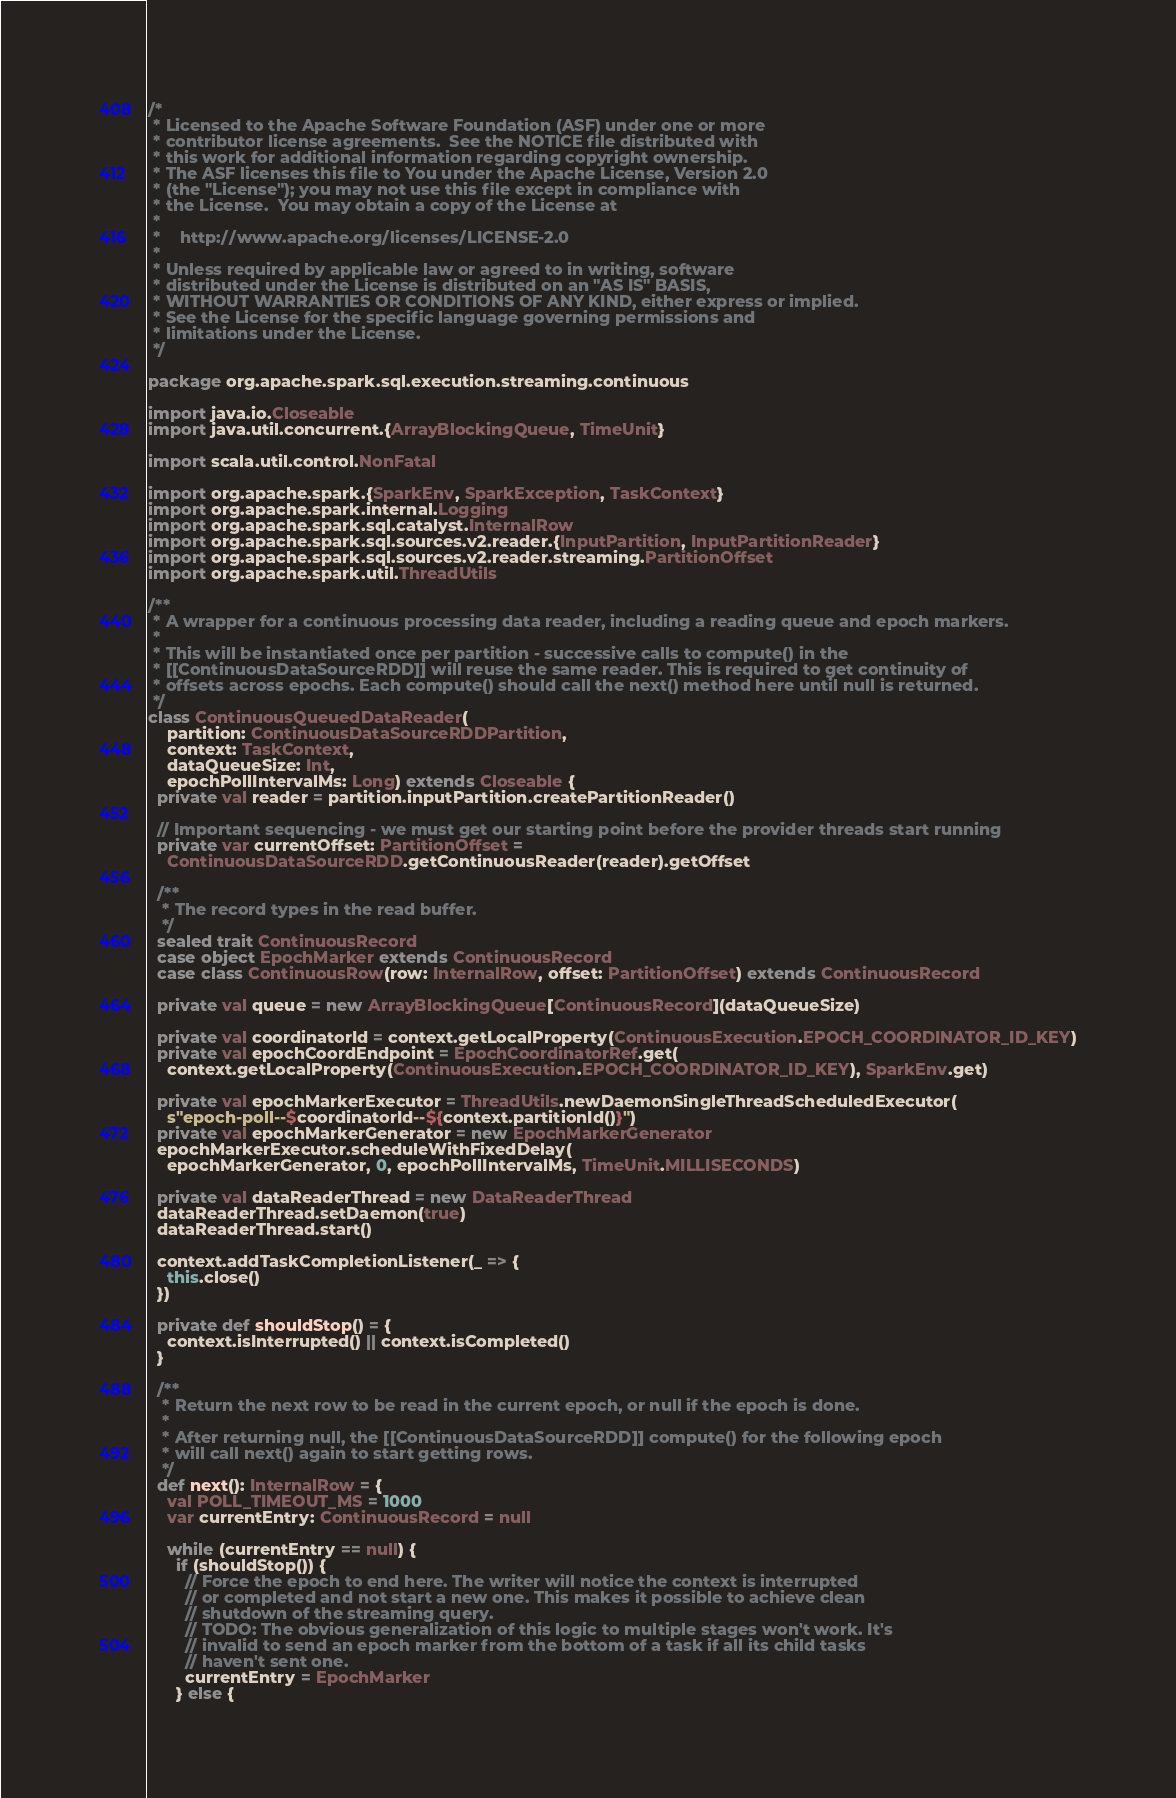<code> <loc_0><loc_0><loc_500><loc_500><_Scala_>/*
 * Licensed to the Apache Software Foundation (ASF) under one or more
 * contributor license agreements.  See the NOTICE file distributed with
 * this work for additional information regarding copyright ownership.
 * The ASF licenses this file to You under the Apache License, Version 2.0
 * (the "License"); you may not use this file except in compliance with
 * the License.  You may obtain a copy of the License at
 *
 *    http://www.apache.org/licenses/LICENSE-2.0
 *
 * Unless required by applicable law or agreed to in writing, software
 * distributed under the License is distributed on an "AS IS" BASIS,
 * WITHOUT WARRANTIES OR CONDITIONS OF ANY KIND, either express or implied.
 * See the License for the specific language governing permissions and
 * limitations under the License.
 */

package org.apache.spark.sql.execution.streaming.continuous

import java.io.Closeable
import java.util.concurrent.{ArrayBlockingQueue, TimeUnit}

import scala.util.control.NonFatal

import org.apache.spark.{SparkEnv, SparkException, TaskContext}
import org.apache.spark.internal.Logging
import org.apache.spark.sql.catalyst.InternalRow
import org.apache.spark.sql.sources.v2.reader.{InputPartition, InputPartitionReader}
import org.apache.spark.sql.sources.v2.reader.streaming.PartitionOffset
import org.apache.spark.util.ThreadUtils

/**
 * A wrapper for a continuous processing data reader, including a reading queue and epoch markers.
 *
 * This will be instantiated once per partition - successive calls to compute() in the
 * [[ContinuousDataSourceRDD]] will reuse the same reader. This is required to get continuity of
 * offsets across epochs. Each compute() should call the next() method here until null is returned.
 */
class ContinuousQueuedDataReader(
    partition: ContinuousDataSourceRDDPartition,
    context: TaskContext,
    dataQueueSize: Int,
    epochPollIntervalMs: Long) extends Closeable {
  private val reader = partition.inputPartition.createPartitionReader()

  // Important sequencing - we must get our starting point before the provider threads start running
  private var currentOffset: PartitionOffset =
    ContinuousDataSourceRDD.getContinuousReader(reader).getOffset

  /**
   * The record types in the read buffer.
   */
  sealed trait ContinuousRecord
  case object EpochMarker extends ContinuousRecord
  case class ContinuousRow(row: InternalRow, offset: PartitionOffset) extends ContinuousRecord

  private val queue = new ArrayBlockingQueue[ContinuousRecord](dataQueueSize)

  private val coordinatorId = context.getLocalProperty(ContinuousExecution.EPOCH_COORDINATOR_ID_KEY)
  private val epochCoordEndpoint = EpochCoordinatorRef.get(
    context.getLocalProperty(ContinuousExecution.EPOCH_COORDINATOR_ID_KEY), SparkEnv.get)

  private val epochMarkerExecutor = ThreadUtils.newDaemonSingleThreadScheduledExecutor(
    s"epoch-poll--$coordinatorId--${context.partitionId()}")
  private val epochMarkerGenerator = new EpochMarkerGenerator
  epochMarkerExecutor.scheduleWithFixedDelay(
    epochMarkerGenerator, 0, epochPollIntervalMs, TimeUnit.MILLISECONDS)

  private val dataReaderThread = new DataReaderThread
  dataReaderThread.setDaemon(true)
  dataReaderThread.start()

  context.addTaskCompletionListener(_ => {
    this.close()
  })

  private def shouldStop() = {
    context.isInterrupted() || context.isCompleted()
  }

  /**
   * Return the next row to be read in the current epoch, or null if the epoch is done.
   *
   * After returning null, the [[ContinuousDataSourceRDD]] compute() for the following epoch
   * will call next() again to start getting rows.
   */
  def next(): InternalRow = {
    val POLL_TIMEOUT_MS = 1000
    var currentEntry: ContinuousRecord = null

    while (currentEntry == null) {
      if (shouldStop()) {
        // Force the epoch to end here. The writer will notice the context is interrupted
        // or completed and not start a new one. This makes it possible to achieve clean
        // shutdown of the streaming query.
        // TODO: The obvious generalization of this logic to multiple stages won't work. It's
        // invalid to send an epoch marker from the bottom of a task if all its child tasks
        // haven't sent one.
        currentEntry = EpochMarker
      } else {</code> 